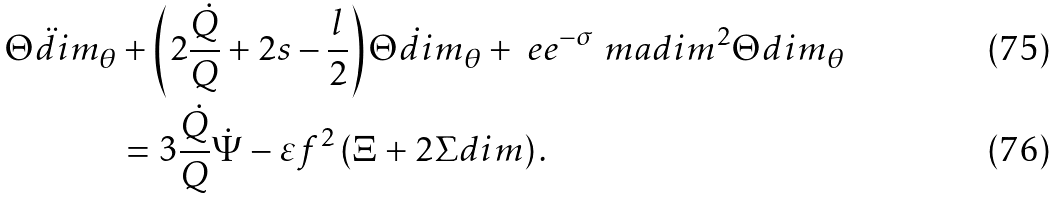Convert formula to latex. <formula><loc_0><loc_0><loc_500><loc_500>\ddot { \Theta d i m } _ { \theta } & + \left ( 2 \frac { \dot { Q } } { Q } + 2 s - \frac { l } { 2 } \right ) \dot { \Theta d i m } _ { \theta } + \ e e ^ { - \sigma } \ m a d i m ^ { 2 } \Theta d i m _ { \theta } \\ & = 3 \frac { \dot { Q } } { Q } \dot { \Psi } - \varepsilon f ^ { 2 } \left ( \Xi + 2 \Sigma d i m \right ) .</formula> 